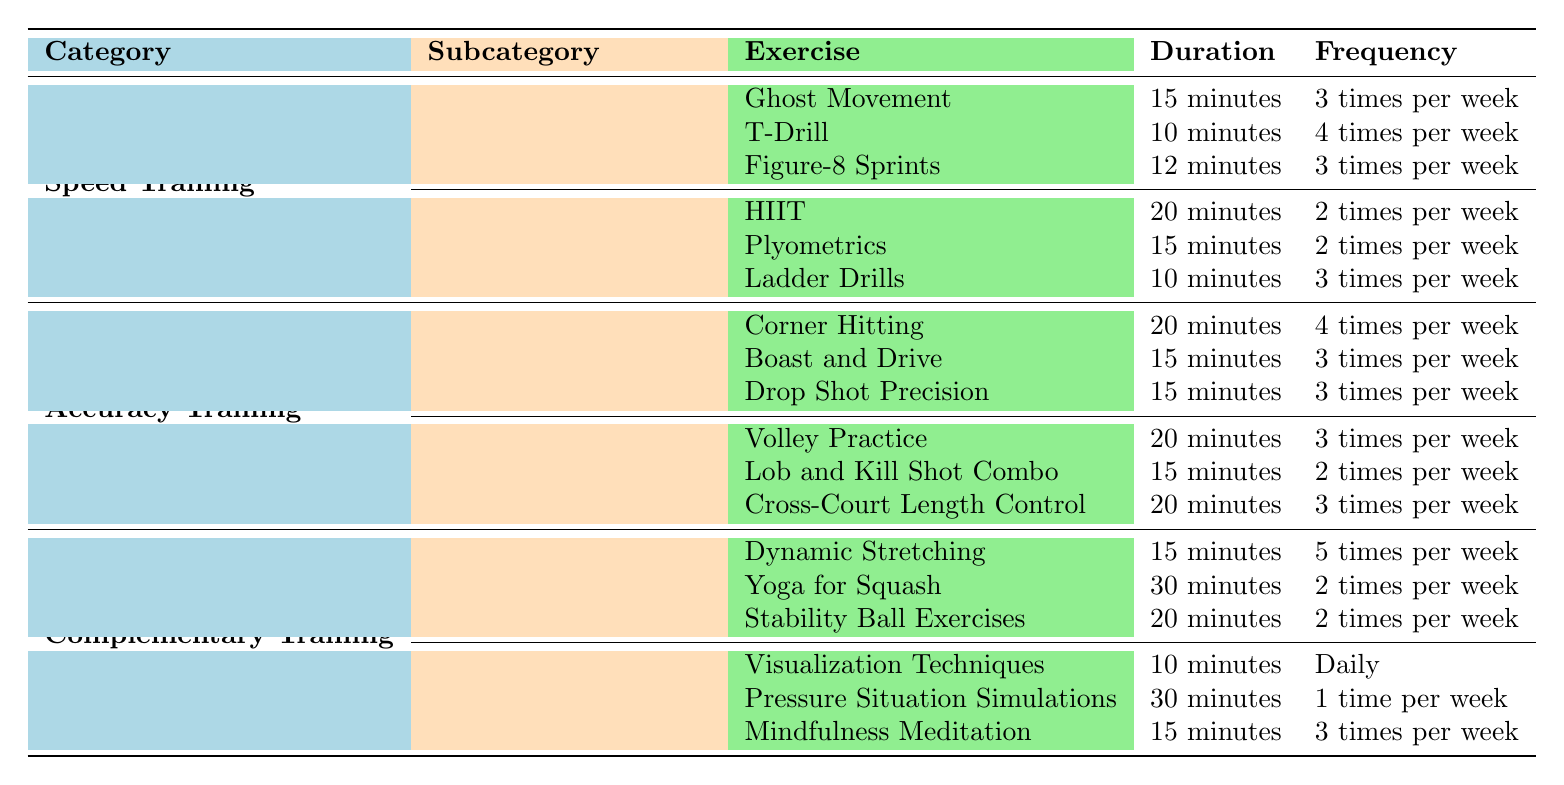What are the total weekly durations for Speed Training on-court drills? The durations for on-court drills are 15 minutes for Ghost Movement, 10 minutes for T-Drill, and 12 minutes for Figure-8 Sprints. Therefore, the total weekly duration for on-court drills = (15 + 10 + 12) minutes per session x (3 sessions for Ghost Movement + 4 sessions for T-Drill + 3 sessions for Figure-8 Sprints) / 3 (for the average number of sessions) = 37 minutes/session.
Answer: 37 minutes How many times per week is the Plyometrics exercise performed? Under Off-Court Conditioning in Speed Training, Plyometrics has a frequency of 2 times per week mentioned in the table.
Answer: 2 times Which Accuracy Training exercise has the highest frequency? The Corner Hitting in Target Practice has a frequency of 4 times per week, which is the highest compared to the other exercises in Accuracy Training.
Answer: Corner Hitting What is the total duration of Accuracy Training in a week? For Target Practice, the total duration is (20 + 15 + 15) minutes per session x (4 + 3 + 3) sessions, thus = 50 minutes/session x 10 sessions = 500 minutes. For Shot Variation, it's (20 + 15 + 20) minutes per session x (3 + 2 + 3) sessions, thus = 55 minutes/session x 8 sessions = 440 minutes. Total for Accuracy Training = 500 + 440 = 940 minutes.
Answer: 940 minutes How often do Mental Training exercises occur weekly compared to Speed Training drills? Mental Training occurs daily for Visualization Techniques, once a week for Pressure Situation Simulations, and 3 times a week for Mindfulness Meditation, totaling to 7 days for Visualization + 1 + 3 = 11 sessions/week. In Speed Training, the three on-court drills occur 3 + 4 + 3 = 10 times a week in total. Since 11 sessions frequently occur in Mental Training, this is more than Speed Training.
Answer: Yes, Mental Training is more frequent What is the average duration of exercises within the Flexibility and Balance subcategory? The exercises are Dynamic Stretching (15 minutes), Yoga for Squash (30 minutes), and Stability Ball Exercises (20 minutes). Average duration = (15 + 30 + 20) / 3 = 65 / 3 = 21.67 minutes.
Answer: 21.67 minutes Identify the category with the least number of times exercises are performed in a week. Complementary Training consists of Flexibility and Balance and Mental Training. Between these, Flexibility and Balance has 5 (Dynamic Stretching) + 2 (Yoga) + 2 (Stability Ball) = 9 times, and Mental Training has 7 (Visualization) + 1 (Pressure Simulations) + 3 (Mindfulness) = 11 times. Thus, Flexibility and Balance has the least with 9 times.
Answer: Flexibility and Balance Which exercise is practiced the least in terms of frequency? The Lob and Kill Shot Combo from the Shot Variation section of Accuracy Training is performed 2 times per week, which is the lowest frequency across all exercises.
Answer: Lob and Kill Shot Combo What is the combined frequency of all speed training exercises listed? The on-court drills have frequencies of 3, 4, and 3, while off-court conditioning has frequencies of 2, 2, and 3. Total = 3 + 4 + 3 + 2 + 2 + 3 = 17 times per week.
Answer: 17 times What is the duration difference between the longest and shortest duration exercises listed in the table? The longest duration is 30 minutes (Yoga for Squash) and the shortest is 10 minutes (T-Drill, Ladder Drills, or Visualization Techniques). The difference is 30 - 10 = 20 minutes.
Answer: 20 minutes 